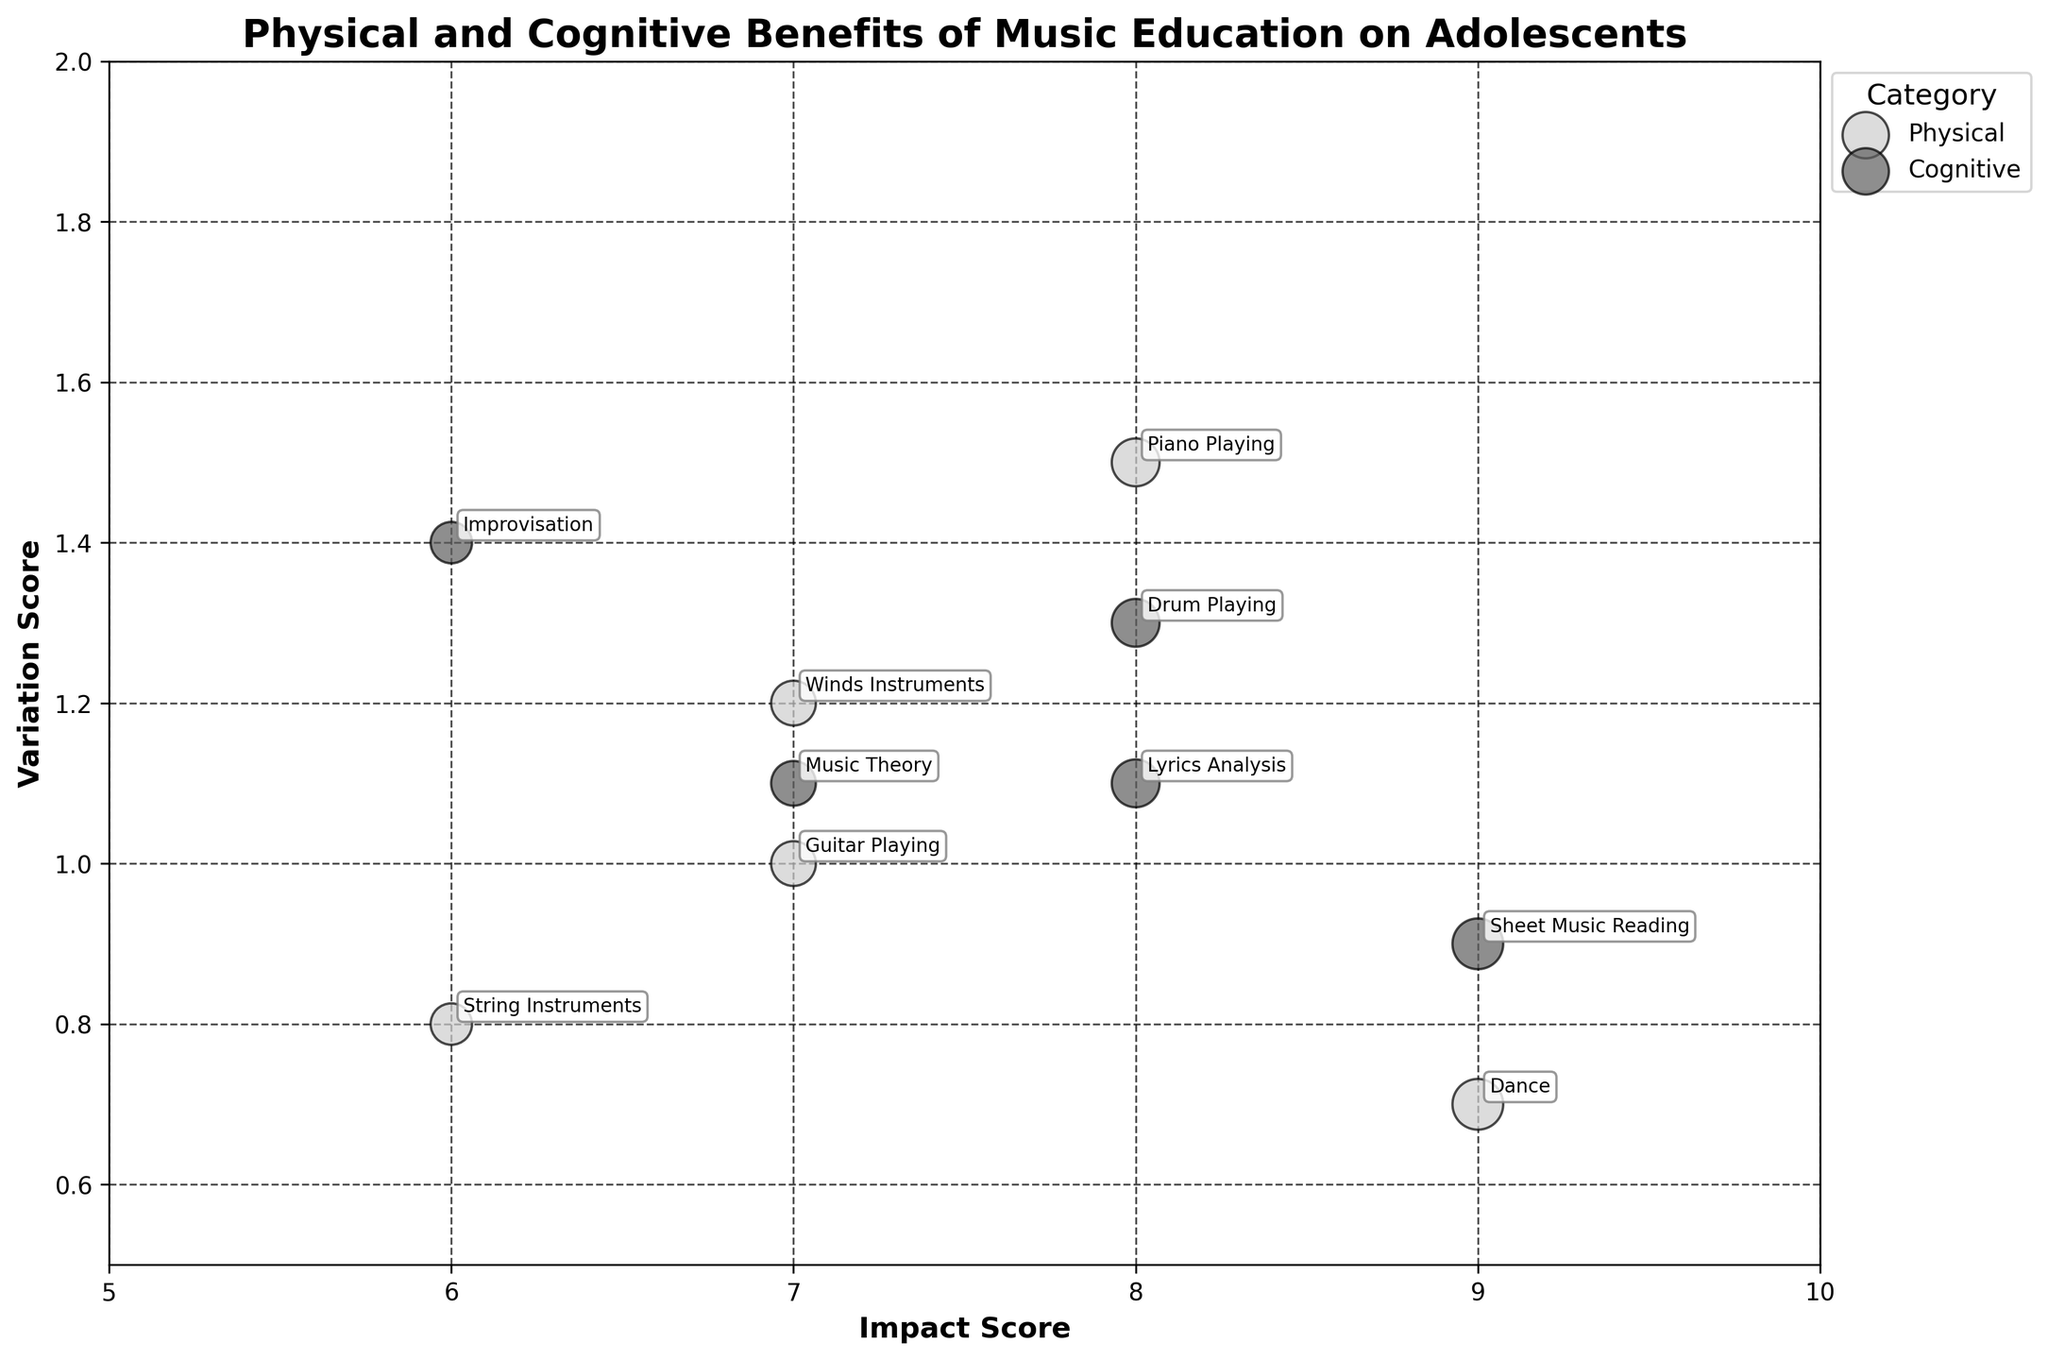What's the title of the figure? The title is typically displayed at the top of the figure and provides a summary of what the figure represents. For this figure, the title tells us what the data is about.
Answer: Physical and Cognitive Benefits of Music Education on Adolescents What are the x-axis and y-axis labels? The x-axis and y-axis labels indicate what each axis represents. For this figure, they show the dimensions of the data.
Answer: Impact Score, Variation Score How many categories are there in the dataset? Categories are visually represented by color on the bubble chart. Each unique color represents a separate category. By counting the distinct colors in the legend, we can determine the number of categories.
Answer: 2 Which category has the highest Impact Score, and what is it? We look for the bubble with the highest Impact Score value on the x-axis. Then we identify the category of that bubble using the color legend.
Answer: Cognitive, 9 Which activity under the Physical category has the lowest Variation Score? We find the bubbles under the Physical category (by looking at their color) and identify the one with the lowest value on the y-axis. Then we note the activity associated with it.
Answer: Dance What is the average Impact Score of the activities in the Physical category? We list out all the Impact Scores for activities under the Physical category: (8, 7, 6, 7, 9). Then we calculate the average by summing them up and dividing by the number of activities. (8+7+6+7+9)/5 = 7.4
Answer: 7.4 What is the difference in Variation Score between the activity with the highest Impact Score and the one with the lowest Impact Score? First, identify the highest Impact Score (9) and its corresponding Variation Score (Dance, 0.7). Then, identify the lowest Impact Score (6) and its corresponding Variation Score (String Instruments, 0.8). Finally, calculate the difference: 0.8 - 0.7 = 0.1
Answer: 0.1 Which activity has the largest bubble size, and what does that size represent? The largest bubble represents the maximum Impact Score. Find the largest bubble and identify its activity. The size is indicative of the Impact Score, and the largest size corresponds to an Impact Score of 9.
Answer: Dance, 9 How many activities have an Impact Score greater than or equal to 8? We count the bubbles where the x-axis (Impact Score) values are 8 or higher.
Answer: 5 Among Cognitive benefits, which activity has the highest Variation Score and what is its value? Look for the cognitive activities (using the color from the legend) and find the one with the highest y-axis value (Variation Score).
Answer: Improvisation, 1.4 